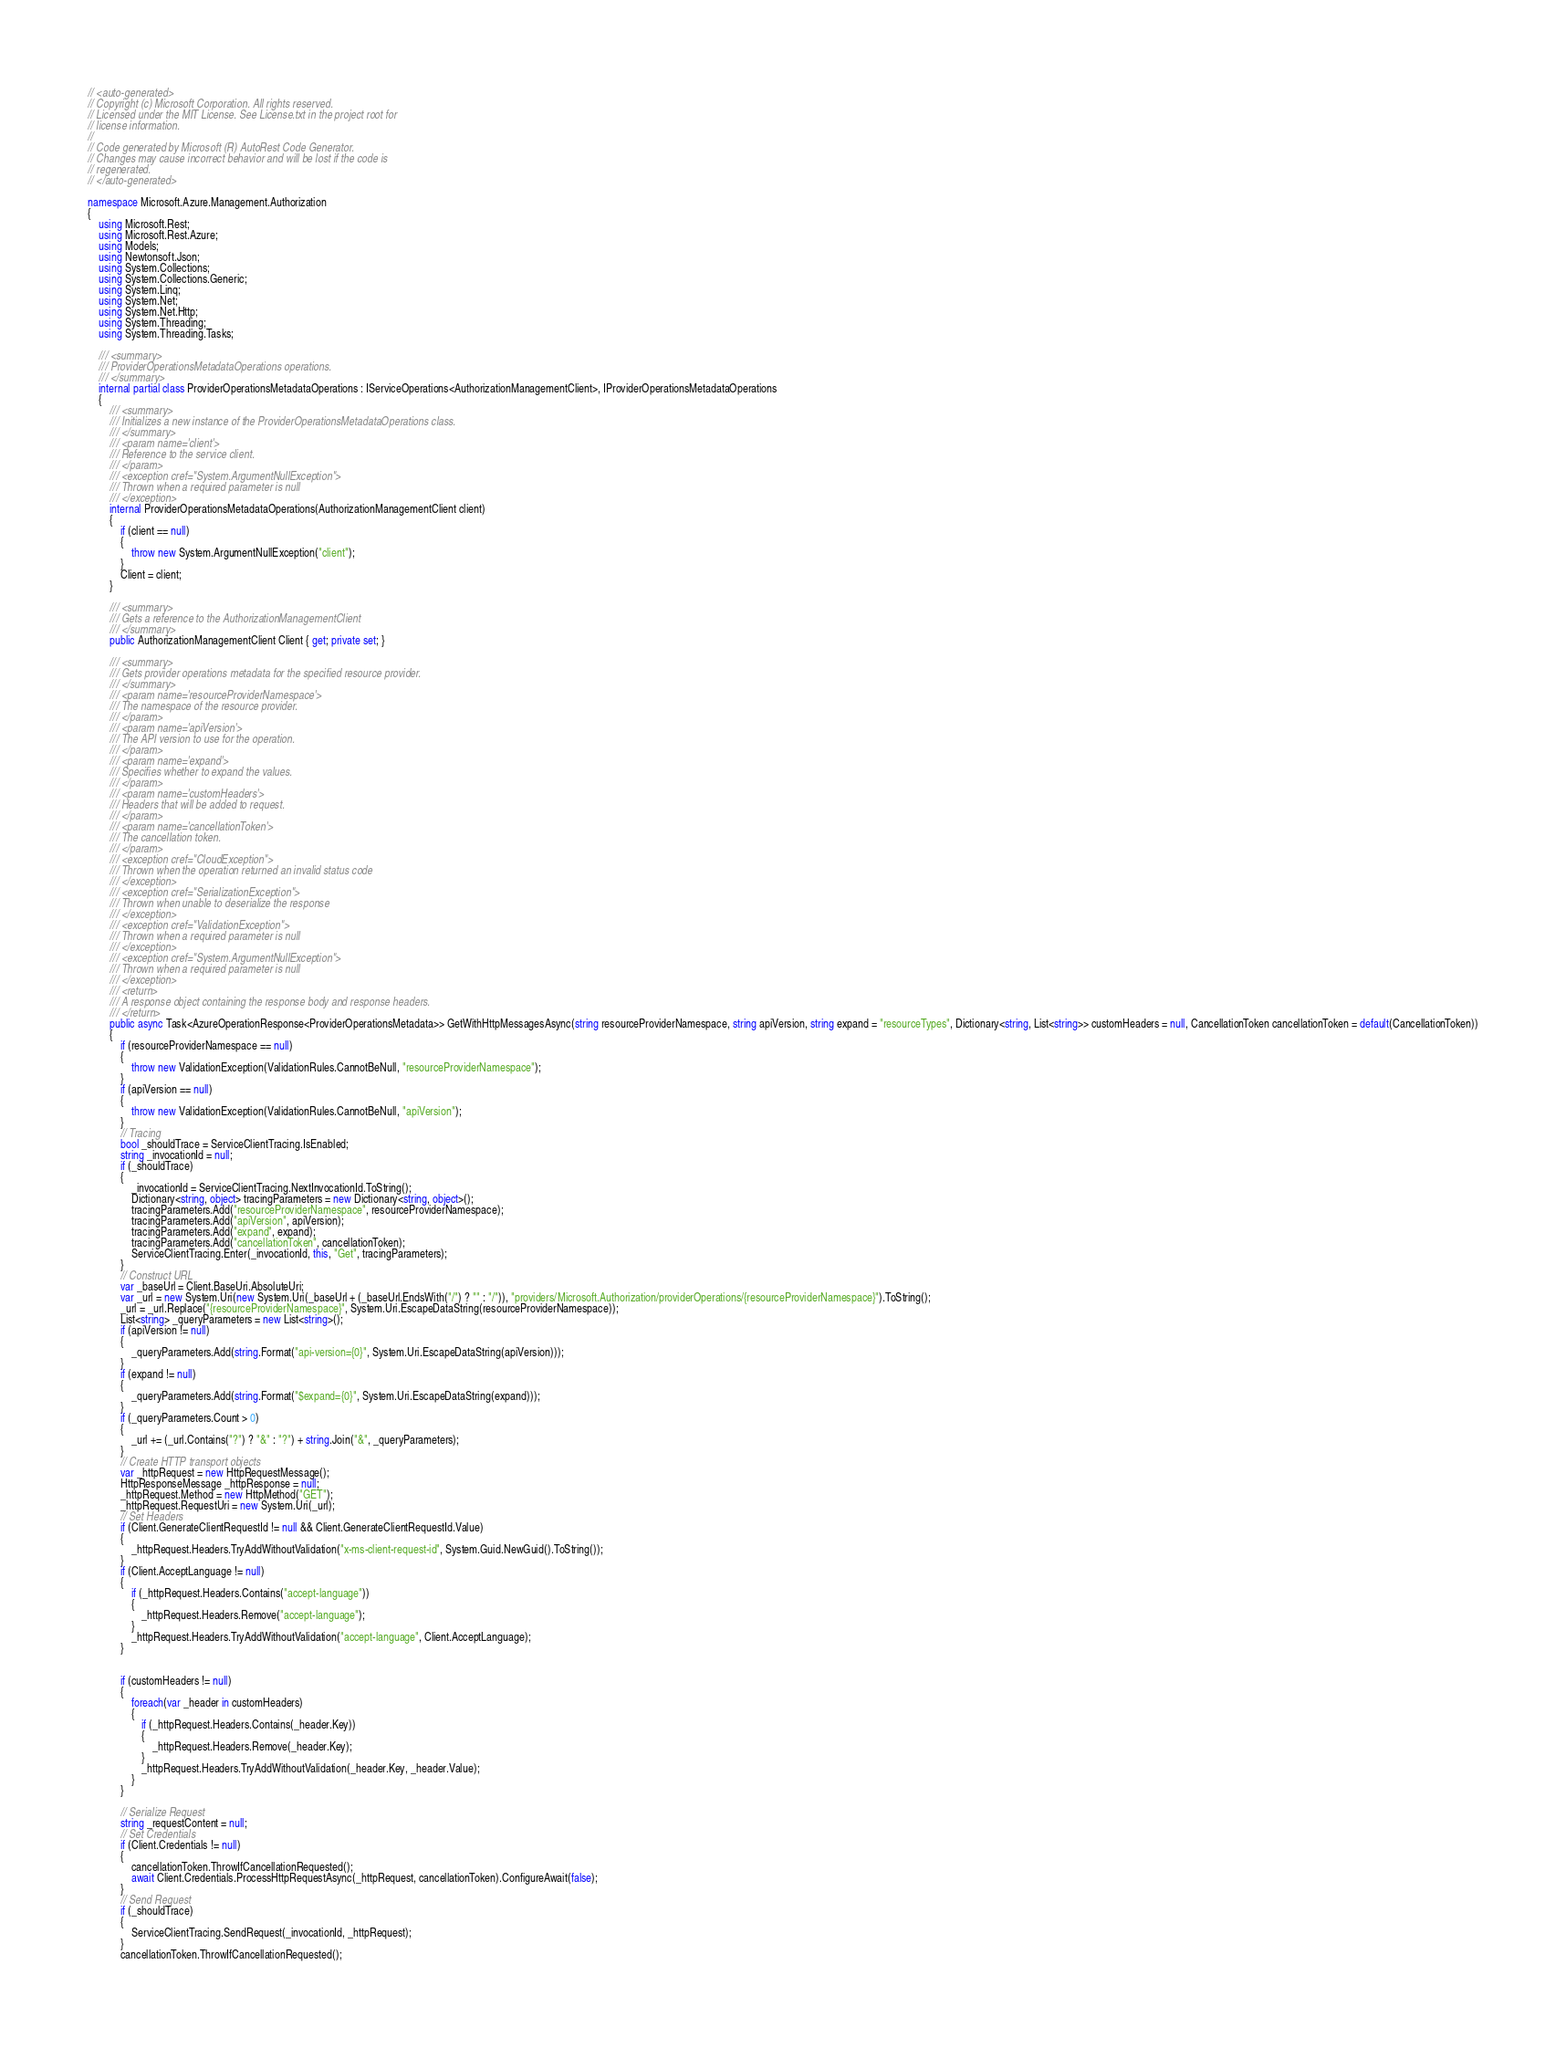<code> <loc_0><loc_0><loc_500><loc_500><_C#_>// <auto-generated>
// Copyright (c) Microsoft Corporation. All rights reserved.
// Licensed under the MIT License. See License.txt in the project root for
// license information.
//
// Code generated by Microsoft (R) AutoRest Code Generator.
// Changes may cause incorrect behavior and will be lost if the code is
// regenerated.
// </auto-generated>

namespace Microsoft.Azure.Management.Authorization
{
    using Microsoft.Rest;
    using Microsoft.Rest.Azure;
    using Models;
    using Newtonsoft.Json;
    using System.Collections;
    using System.Collections.Generic;
    using System.Linq;
    using System.Net;
    using System.Net.Http;
    using System.Threading;
    using System.Threading.Tasks;

    /// <summary>
    /// ProviderOperationsMetadataOperations operations.
    /// </summary>
    internal partial class ProviderOperationsMetadataOperations : IServiceOperations<AuthorizationManagementClient>, IProviderOperationsMetadataOperations
    {
        /// <summary>
        /// Initializes a new instance of the ProviderOperationsMetadataOperations class.
        /// </summary>
        /// <param name='client'>
        /// Reference to the service client.
        /// </param>
        /// <exception cref="System.ArgumentNullException">
        /// Thrown when a required parameter is null
        /// </exception>
        internal ProviderOperationsMetadataOperations(AuthorizationManagementClient client)
        {
            if (client == null)
            {
                throw new System.ArgumentNullException("client");
            }
            Client = client;
        }

        /// <summary>
        /// Gets a reference to the AuthorizationManagementClient
        /// </summary>
        public AuthorizationManagementClient Client { get; private set; }

        /// <summary>
        /// Gets provider operations metadata for the specified resource provider.
        /// </summary>
        /// <param name='resourceProviderNamespace'>
        /// The namespace of the resource provider.
        /// </param>
        /// <param name='apiVersion'>
        /// The API version to use for the operation.
        /// </param>
        /// <param name='expand'>
        /// Specifies whether to expand the values.
        /// </param>
        /// <param name='customHeaders'>
        /// Headers that will be added to request.
        /// </param>
        /// <param name='cancellationToken'>
        /// The cancellation token.
        /// </param>
        /// <exception cref="CloudException">
        /// Thrown when the operation returned an invalid status code
        /// </exception>
        /// <exception cref="SerializationException">
        /// Thrown when unable to deserialize the response
        /// </exception>
        /// <exception cref="ValidationException">
        /// Thrown when a required parameter is null
        /// </exception>
        /// <exception cref="System.ArgumentNullException">
        /// Thrown when a required parameter is null
        /// </exception>
        /// <return>
        /// A response object containing the response body and response headers.
        /// </return>
        public async Task<AzureOperationResponse<ProviderOperationsMetadata>> GetWithHttpMessagesAsync(string resourceProviderNamespace, string apiVersion, string expand = "resourceTypes", Dictionary<string, List<string>> customHeaders = null, CancellationToken cancellationToken = default(CancellationToken))
        {
            if (resourceProviderNamespace == null)
            {
                throw new ValidationException(ValidationRules.CannotBeNull, "resourceProviderNamespace");
            }
            if (apiVersion == null)
            {
                throw new ValidationException(ValidationRules.CannotBeNull, "apiVersion");
            }
            // Tracing
            bool _shouldTrace = ServiceClientTracing.IsEnabled;
            string _invocationId = null;
            if (_shouldTrace)
            {
                _invocationId = ServiceClientTracing.NextInvocationId.ToString();
                Dictionary<string, object> tracingParameters = new Dictionary<string, object>();
                tracingParameters.Add("resourceProviderNamespace", resourceProviderNamespace);
                tracingParameters.Add("apiVersion", apiVersion);
                tracingParameters.Add("expand", expand);
                tracingParameters.Add("cancellationToken", cancellationToken);
                ServiceClientTracing.Enter(_invocationId, this, "Get", tracingParameters);
            }
            // Construct URL
            var _baseUrl = Client.BaseUri.AbsoluteUri;
            var _url = new System.Uri(new System.Uri(_baseUrl + (_baseUrl.EndsWith("/") ? "" : "/")), "providers/Microsoft.Authorization/providerOperations/{resourceProviderNamespace}").ToString();
            _url = _url.Replace("{resourceProviderNamespace}", System.Uri.EscapeDataString(resourceProviderNamespace));
            List<string> _queryParameters = new List<string>();
            if (apiVersion != null)
            {
                _queryParameters.Add(string.Format("api-version={0}", System.Uri.EscapeDataString(apiVersion)));
            }
            if (expand != null)
            {
                _queryParameters.Add(string.Format("$expand={0}", System.Uri.EscapeDataString(expand)));
            }
            if (_queryParameters.Count > 0)
            {
                _url += (_url.Contains("?") ? "&" : "?") + string.Join("&", _queryParameters);
            }
            // Create HTTP transport objects
            var _httpRequest = new HttpRequestMessage();
            HttpResponseMessage _httpResponse = null;
            _httpRequest.Method = new HttpMethod("GET");
            _httpRequest.RequestUri = new System.Uri(_url);
            // Set Headers
            if (Client.GenerateClientRequestId != null && Client.GenerateClientRequestId.Value)
            {
                _httpRequest.Headers.TryAddWithoutValidation("x-ms-client-request-id", System.Guid.NewGuid().ToString());
            }
            if (Client.AcceptLanguage != null)
            {
                if (_httpRequest.Headers.Contains("accept-language"))
                {
                    _httpRequest.Headers.Remove("accept-language");
                }
                _httpRequest.Headers.TryAddWithoutValidation("accept-language", Client.AcceptLanguage);
            }


            if (customHeaders != null)
            {
                foreach(var _header in customHeaders)
                {
                    if (_httpRequest.Headers.Contains(_header.Key))
                    {
                        _httpRequest.Headers.Remove(_header.Key);
                    }
                    _httpRequest.Headers.TryAddWithoutValidation(_header.Key, _header.Value);
                }
            }

            // Serialize Request
            string _requestContent = null;
            // Set Credentials
            if (Client.Credentials != null)
            {
                cancellationToken.ThrowIfCancellationRequested();
                await Client.Credentials.ProcessHttpRequestAsync(_httpRequest, cancellationToken).ConfigureAwait(false);
            }
            // Send Request
            if (_shouldTrace)
            {
                ServiceClientTracing.SendRequest(_invocationId, _httpRequest);
            }
            cancellationToken.ThrowIfCancellationRequested();</code> 